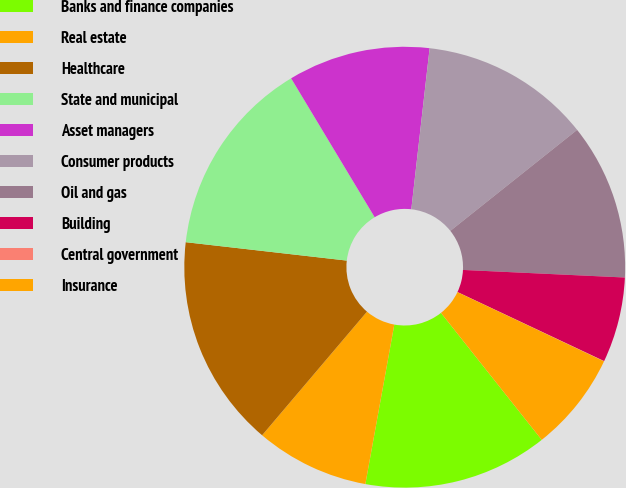Convert chart. <chart><loc_0><loc_0><loc_500><loc_500><pie_chart><fcel>Banks and finance companies<fcel>Real estate<fcel>Healthcare<fcel>State and municipal<fcel>Asset managers<fcel>Consumer products<fcel>Oil and gas<fcel>Building<fcel>Central government<fcel>Insurance<nl><fcel>13.53%<fcel>8.34%<fcel>15.61%<fcel>14.57%<fcel>10.42%<fcel>12.49%<fcel>11.45%<fcel>6.26%<fcel>0.02%<fcel>7.3%<nl></chart> 